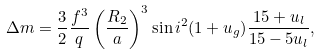Convert formula to latex. <formula><loc_0><loc_0><loc_500><loc_500>\Delta m = \frac { 3 } { 2 } \frac { f ^ { 3 } } { q } \left ( \frac { R _ { 2 } } { a } \right ) ^ { 3 } \sin { i } ^ { 2 } ( 1 + u _ { g } ) \frac { 1 5 + u _ { l } } { 1 5 - 5 u _ { l } } ,</formula> 